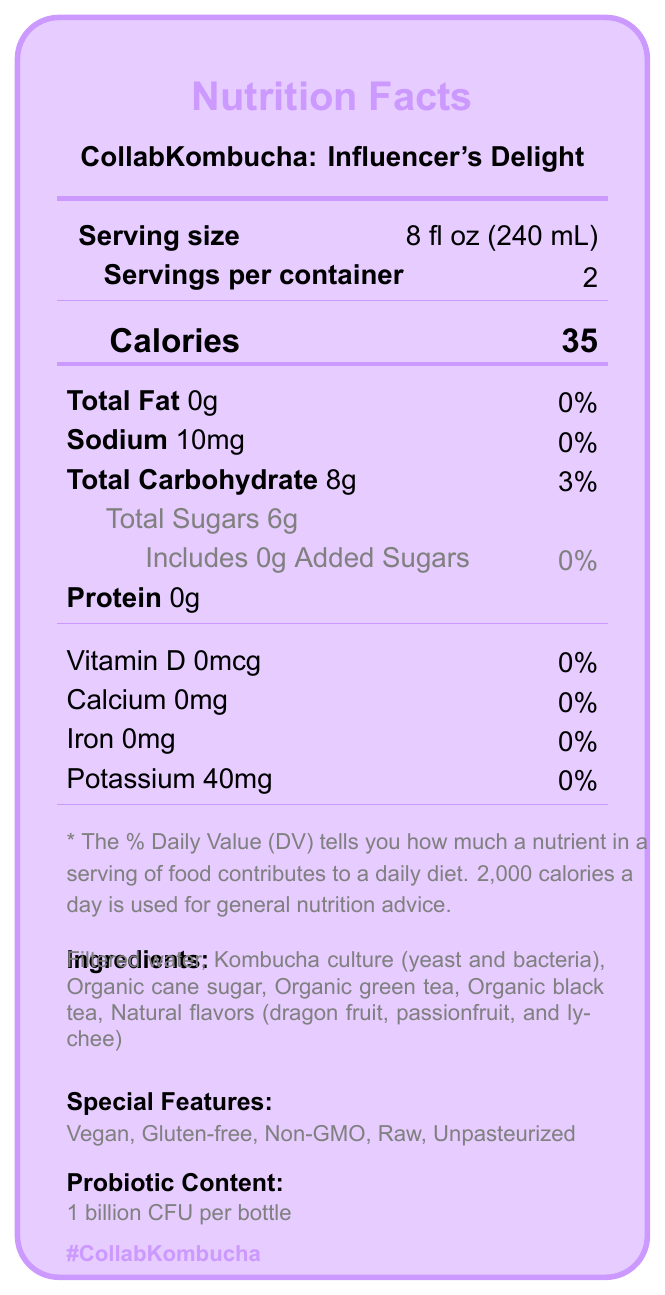what is the serving size? The serving size is specifically listed as "8 fl oz (240 mL)" under the "Serving size" section.
Answer: 8 fl oz (240 mL) how many calories are there per serving? The "Calories" section lists 35 calories per serving.
Answer: 35 how much sodium is in one serving? The "Sodium" section lists the amount of sodium as 10mg.
Answer: 10mg how much total carbohydrate does a serving contain? The "Total Carbohydrate" section lists 8g per serving.
Answer: 8g which ingredients are used in CollabKombucha: Influencer's Delight? The ingredients are listed in the "Ingredients" section.
Answer: Filtered water, Kombucha culture (yeast and bacteria), Organic cane sugar, Organic green tea, Organic black tea, Natural flavors (dragon fruit, passionfruit, and lychee) how many servings are there per container? A. 1 B. 2 C. 3 The "Servings per container" section states there are 2 servings per container.
Answer: B how much added sugar does the product contain? A. 0g B. 6g C. 8g D. 10mg The "Includes 0g Added Sugars" line under "Total Sugars" confirms there is 0g of added sugar.
Answer: A does the product contain any protein? The "Protein" section lists "0g," indicating there is no protein in the product.
Answer: No is CollabKombucha gluten-free? The "Special Features" section indicates that the product is gluten-free.
Answer: Yes does the document specify the carbon footprint of the product? The document does not provide any information regarding the carbon footprint of the product.
Answer: Not enough information describe the main features of the product based on the document The description includes information about the product name, serving size, servings per container, calorie content, special dietary features, probiotic content, packaging, flavor profile, allergens, collaborator details, limited-edition status, social media hashtag, and website URL.
Answer: CollabKombucha: Influencer's Delight is a limited-edition kombucha created in collaboration with @HealthyLivingGuru and @KombuchaQueen. It contains 35 calories per 8 fl oz serving, with 2 servings per container. It has no fat, protein, or added sugars, and it is vegan, gluten-free, non-GMO, raw, and unpasteurized. The product is high in probiotics with 1 billion CFU per bottle and is packaged in a recyclable glass bottle. The flavors include dragon fruit, passionfruit, and lychee. It is produced in a facility that also processes soy and tree nuts. Use hashtag #CollabKombucha for social media engagements. Check www.collabkombucha.com for more details. 